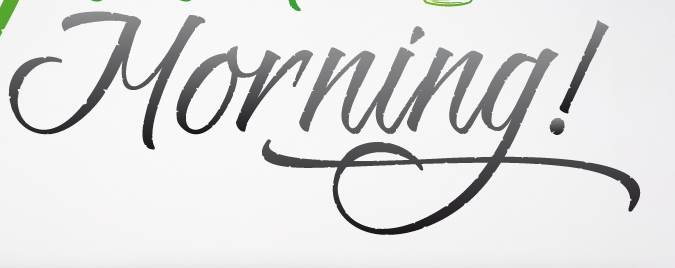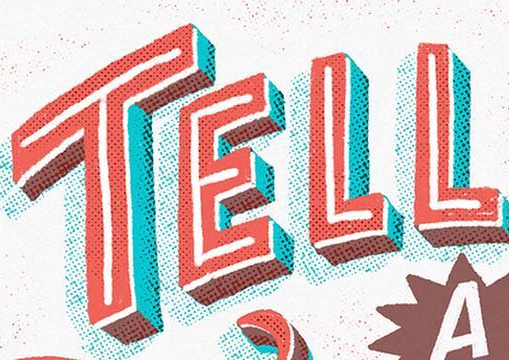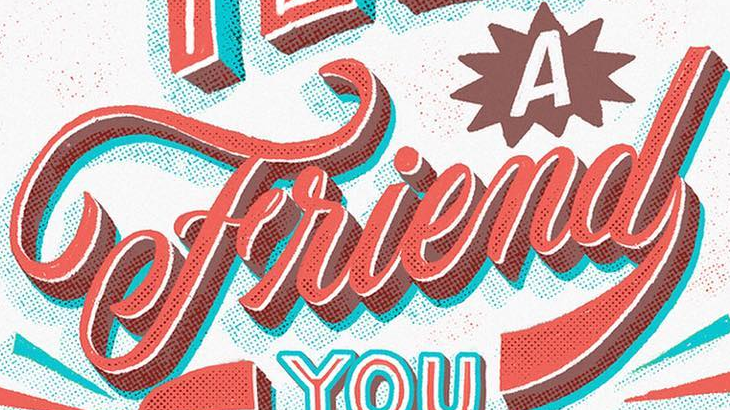What words are shown in these images in order, separated by a semicolon? Morning!; TELL; Friend 